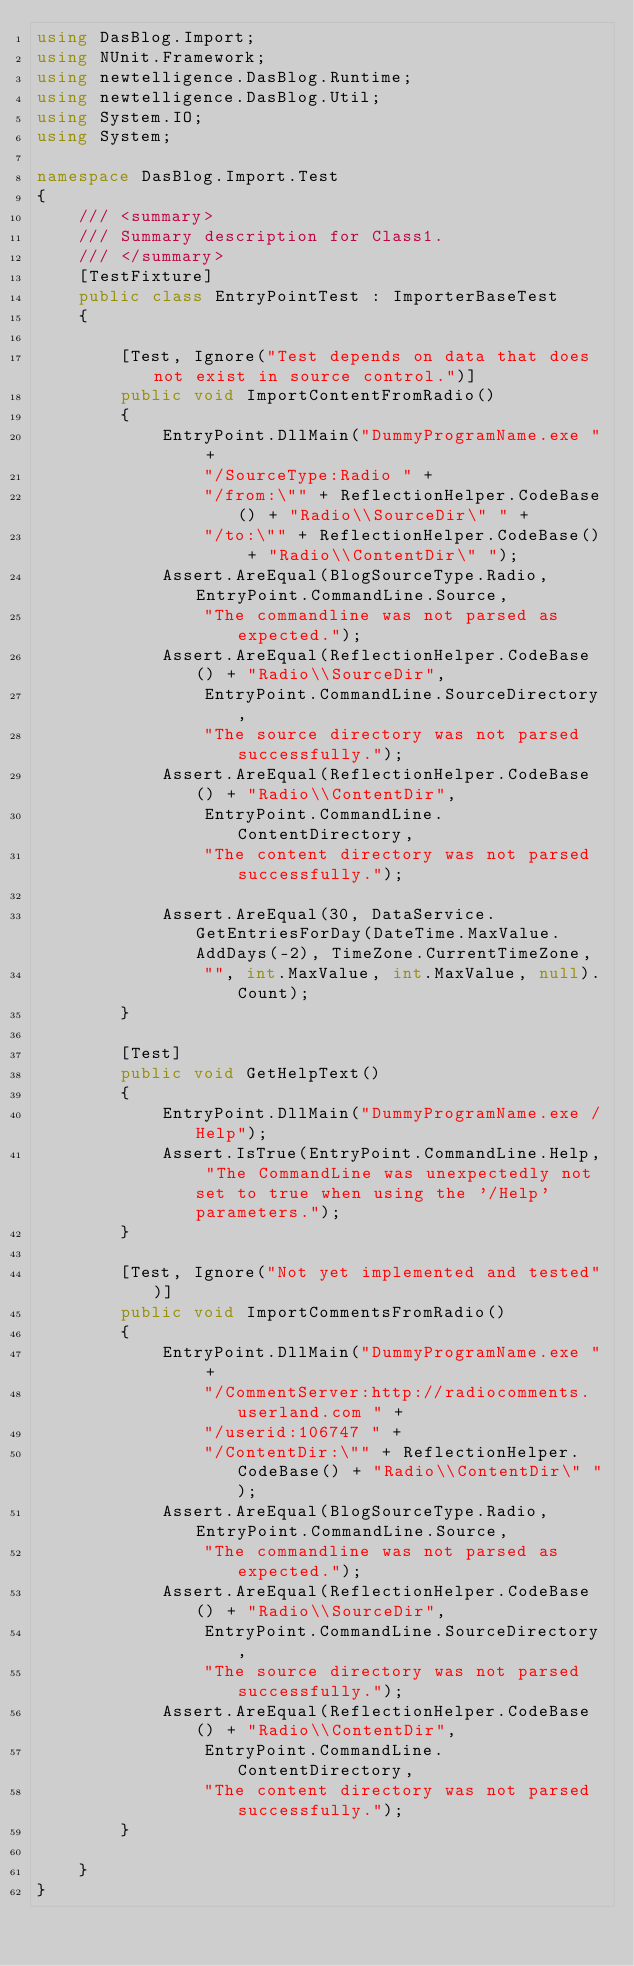Convert code to text. <code><loc_0><loc_0><loc_500><loc_500><_C#_>using DasBlog.Import;
using NUnit.Framework;
using newtelligence.DasBlog.Runtime;
using newtelligence.DasBlog.Util;
using System.IO;
using System;

namespace DasBlog.Import.Test
{
	/// <summary>
	/// Summary description for Class1.
	/// </summary>
	[TestFixture]
	public class EntryPointTest : ImporterBaseTest
	{

		[Test, Ignore("Test depends on data that does not exist in source control.")]
		public void ImportContentFromRadio()
		{
			EntryPoint.DllMain("DummyProgramName.exe " +
				"/SourceType:Radio " +
				"/from:\"" + ReflectionHelper.CodeBase() + "Radio\\SourceDir\" " +
				"/to:\"" + ReflectionHelper.CodeBase() + "Radio\\ContentDir\" ");
			Assert.AreEqual(BlogSourceType.Radio, EntryPoint.CommandLine.Source, 
				"The commandline was not parsed as expected.");
			Assert.AreEqual(ReflectionHelper.CodeBase() + "Radio\\SourceDir", 
				EntryPoint.CommandLine.SourceDirectory, 
				"The source directory was not parsed successfully.");
			Assert.AreEqual(ReflectionHelper.CodeBase() + "Radio\\ContentDir", 
				EntryPoint.CommandLine.ContentDirectory,
				"The content directory was not parsed successfully.");

			Assert.AreEqual(30, DataService.GetEntriesForDay(DateTime.MaxValue.AddDays(-2), TimeZone.CurrentTimeZone,
				"", int.MaxValue, int.MaxValue, null).Count);	
		}

		[Test]
		public void GetHelpText()
		{
			EntryPoint.DllMain("DummyProgramName.exe /Help");
			Assert.IsTrue(EntryPoint.CommandLine.Help, "The CommandLine was unexpectedly not set to true when using the '/Help' parameters.");
		}

		[Test, Ignore("Not yet implemented and tested")]
		public void ImportCommentsFromRadio()
		{
			EntryPoint.DllMain("DummyProgramName.exe " +
				"/CommentServer:http://radiocomments.userland.com " +
				"/userid:106747 " +
				"/ContentDir:\"" + ReflectionHelper.CodeBase() + "Radio\\ContentDir\" ");
			Assert.AreEqual(BlogSourceType.Radio, EntryPoint.CommandLine.Source, 
				"The commandline was not parsed as expected.");
			Assert.AreEqual(ReflectionHelper.CodeBase() + "Radio\\SourceDir", 
				EntryPoint.CommandLine.SourceDirectory, 
				"The source directory was not parsed successfully.");
			Assert.AreEqual(ReflectionHelper.CodeBase() + "Radio\\ContentDir", 
				EntryPoint.CommandLine.ContentDirectory,
				"The content directory was not parsed successfully.");
		}

	}
}
</code> 